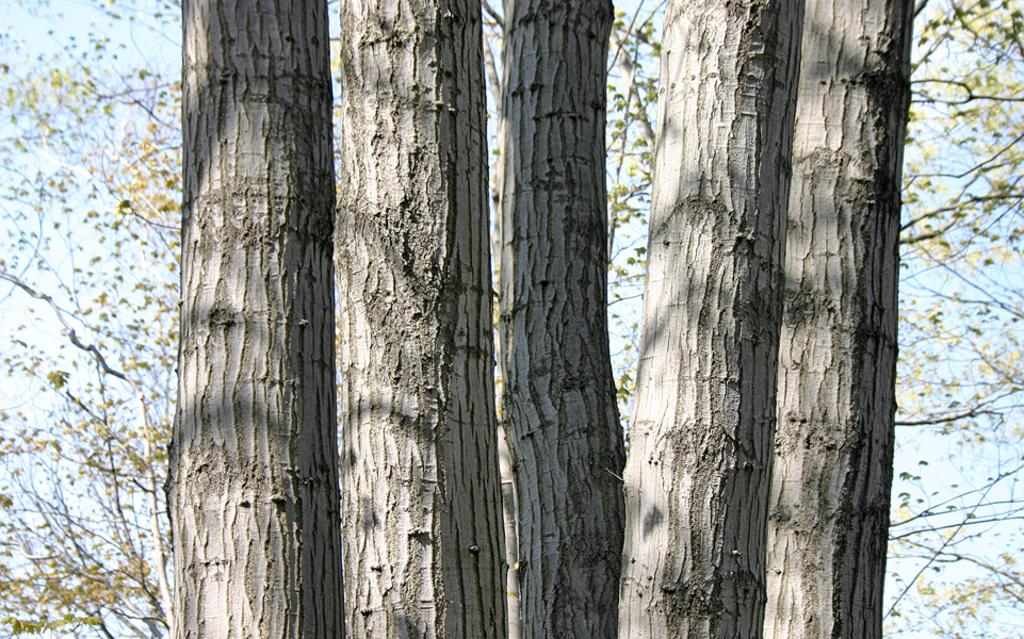How many tree trunks are visible in the image? There are four tree trunks in the image. What else can be seen in the background of the image? There are branches with leaves visible in the background of the image. What type of produce is being sold at the camp in the image? There is no produce or camp present in the image; it features tree trunks and branches with leaves. 